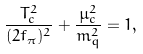<formula> <loc_0><loc_0><loc_500><loc_500>\frac { T ^ { 2 } _ { c } } { ( 2 f _ { \pi } ) ^ { 2 } } + \frac { \mu _ { c } ^ { 2 } } { m ^ { 2 } _ { q } } = 1 ,</formula> 